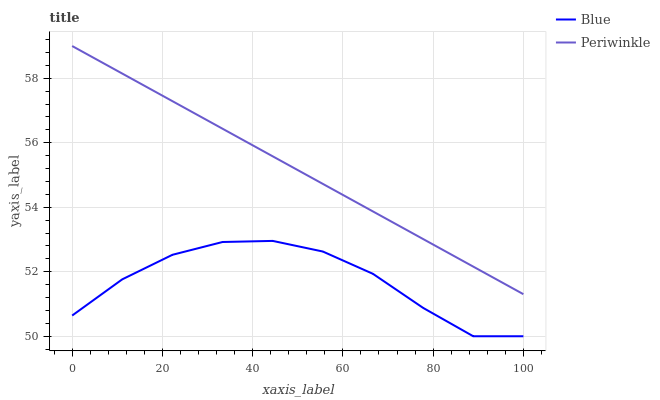Does Blue have the minimum area under the curve?
Answer yes or no. Yes. Does Periwinkle have the maximum area under the curve?
Answer yes or no. Yes. Does Periwinkle have the minimum area under the curve?
Answer yes or no. No. Is Periwinkle the smoothest?
Answer yes or no. Yes. Is Blue the roughest?
Answer yes or no. Yes. Is Periwinkle the roughest?
Answer yes or no. No. Does Periwinkle have the lowest value?
Answer yes or no. No. Does Periwinkle have the highest value?
Answer yes or no. Yes. Is Blue less than Periwinkle?
Answer yes or no. Yes. Is Periwinkle greater than Blue?
Answer yes or no. Yes. Does Blue intersect Periwinkle?
Answer yes or no. No. 